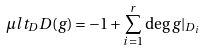<formula> <loc_0><loc_0><loc_500><loc_500>\mu l t _ { D } D ( g ) = - 1 + \sum _ { i = 1 } ^ { r } \deg g | _ { D _ { i } }</formula> 